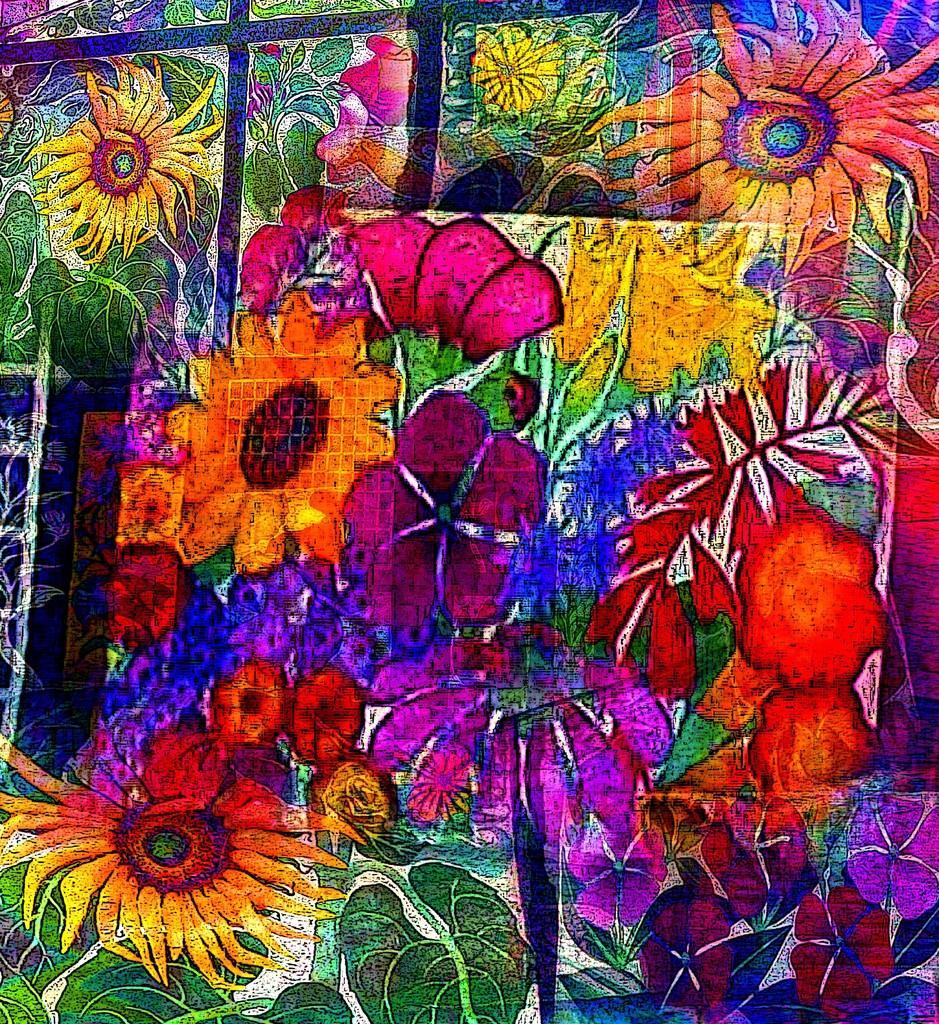How would you summarize this image in a sentence or two? In this picture there are few flowers and some other objects which are in different colors. 